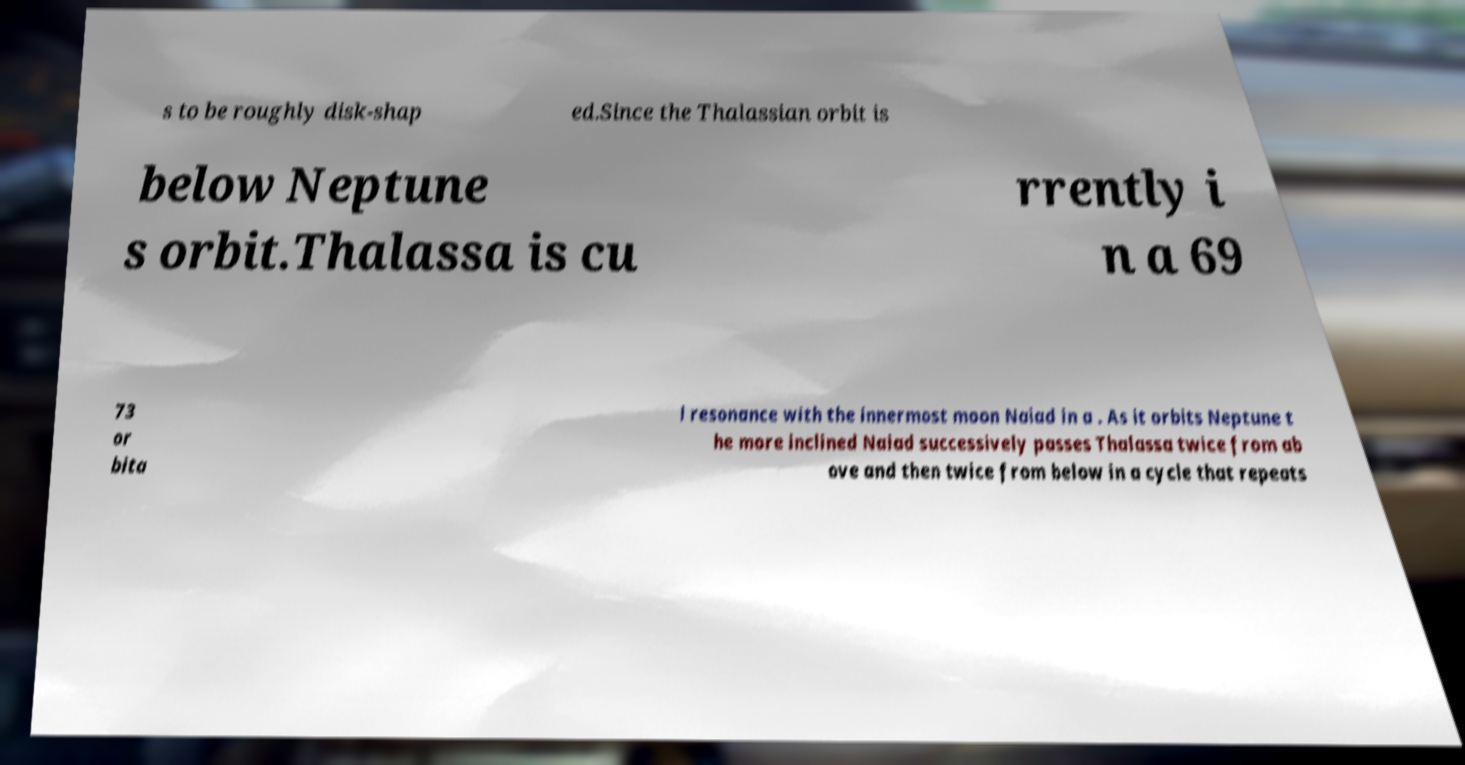Please read and relay the text visible in this image. What does it say? s to be roughly disk-shap ed.Since the Thalassian orbit is below Neptune s orbit.Thalassa is cu rrently i n a 69 73 or bita l resonance with the innermost moon Naiad in a . As it orbits Neptune t he more inclined Naiad successively passes Thalassa twice from ab ove and then twice from below in a cycle that repeats 